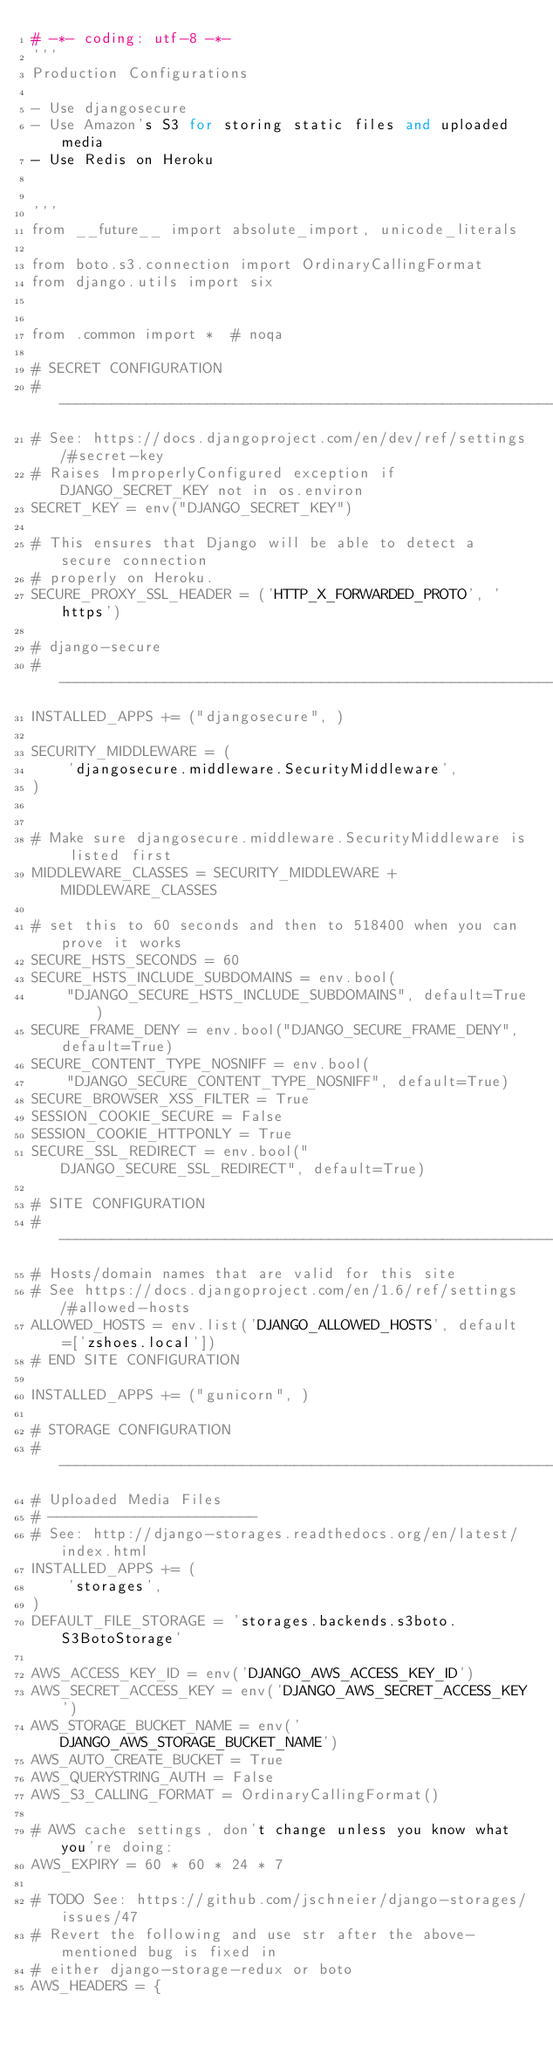<code> <loc_0><loc_0><loc_500><loc_500><_Python_># -*- coding: utf-8 -*-
'''
Production Configurations

- Use djangosecure
- Use Amazon's S3 for storing static files and uploaded media
- Use Redis on Heroku


'''
from __future__ import absolute_import, unicode_literals

from boto.s3.connection import OrdinaryCallingFormat
from django.utils import six


from .common import *  # noqa

# SECRET CONFIGURATION
# ------------------------------------------------------------------------------
# See: https://docs.djangoproject.com/en/dev/ref/settings/#secret-key
# Raises ImproperlyConfigured exception if DJANGO_SECRET_KEY not in os.environ
SECRET_KEY = env("DJANGO_SECRET_KEY")

# This ensures that Django will be able to detect a secure connection
# properly on Heroku.
SECURE_PROXY_SSL_HEADER = ('HTTP_X_FORWARDED_PROTO', 'https')

# django-secure
# ------------------------------------------------------------------------------
INSTALLED_APPS += ("djangosecure", )

SECURITY_MIDDLEWARE = (
    'djangosecure.middleware.SecurityMiddleware',
)


# Make sure djangosecure.middleware.SecurityMiddleware is listed first
MIDDLEWARE_CLASSES = SECURITY_MIDDLEWARE + MIDDLEWARE_CLASSES

# set this to 60 seconds and then to 518400 when you can prove it works
SECURE_HSTS_SECONDS = 60
SECURE_HSTS_INCLUDE_SUBDOMAINS = env.bool(
    "DJANGO_SECURE_HSTS_INCLUDE_SUBDOMAINS", default=True)
SECURE_FRAME_DENY = env.bool("DJANGO_SECURE_FRAME_DENY", default=True)
SECURE_CONTENT_TYPE_NOSNIFF = env.bool(
    "DJANGO_SECURE_CONTENT_TYPE_NOSNIFF", default=True)
SECURE_BROWSER_XSS_FILTER = True
SESSION_COOKIE_SECURE = False
SESSION_COOKIE_HTTPONLY = True
SECURE_SSL_REDIRECT = env.bool("DJANGO_SECURE_SSL_REDIRECT", default=True)

# SITE CONFIGURATION
# ------------------------------------------------------------------------------
# Hosts/domain names that are valid for this site
# See https://docs.djangoproject.com/en/1.6/ref/settings/#allowed-hosts
ALLOWED_HOSTS = env.list('DJANGO_ALLOWED_HOSTS', default=['zshoes.local'])
# END SITE CONFIGURATION

INSTALLED_APPS += ("gunicorn", )

# STORAGE CONFIGURATION
# ------------------------------------------------------------------------------
# Uploaded Media Files
# ------------------------
# See: http://django-storages.readthedocs.org/en/latest/index.html
INSTALLED_APPS += (
    'storages',
)
DEFAULT_FILE_STORAGE = 'storages.backends.s3boto.S3BotoStorage'

AWS_ACCESS_KEY_ID = env('DJANGO_AWS_ACCESS_KEY_ID')
AWS_SECRET_ACCESS_KEY = env('DJANGO_AWS_SECRET_ACCESS_KEY')
AWS_STORAGE_BUCKET_NAME = env('DJANGO_AWS_STORAGE_BUCKET_NAME')
AWS_AUTO_CREATE_BUCKET = True
AWS_QUERYSTRING_AUTH = False
AWS_S3_CALLING_FORMAT = OrdinaryCallingFormat()

# AWS cache settings, don't change unless you know what you're doing:
AWS_EXPIRY = 60 * 60 * 24 * 7

# TODO See: https://github.com/jschneier/django-storages/issues/47
# Revert the following and use str after the above-mentioned bug is fixed in
# either django-storage-redux or boto
AWS_HEADERS = {</code> 